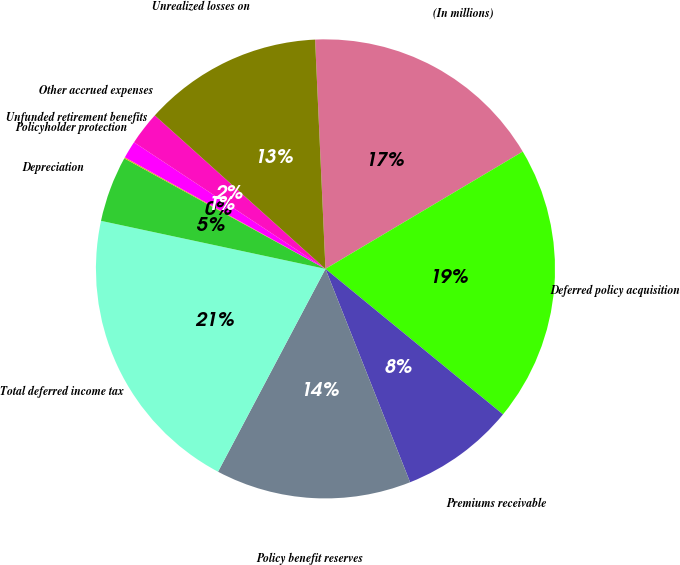Convert chart to OTSL. <chart><loc_0><loc_0><loc_500><loc_500><pie_chart><fcel>(In millions)<fcel>Deferred policy acquisition<fcel>Premiums receivable<fcel>Policy benefit reserves<fcel>Total deferred income tax<fcel>Depreciation<fcel>Policyholder protection<fcel>Unfunded retirement benefits<fcel>Other accrued expenses<fcel>Unrealized losses on<nl><fcel>17.18%<fcel>19.46%<fcel>8.06%<fcel>13.76%<fcel>20.6%<fcel>4.64%<fcel>0.08%<fcel>1.22%<fcel>2.36%<fcel>12.62%<nl></chart> 